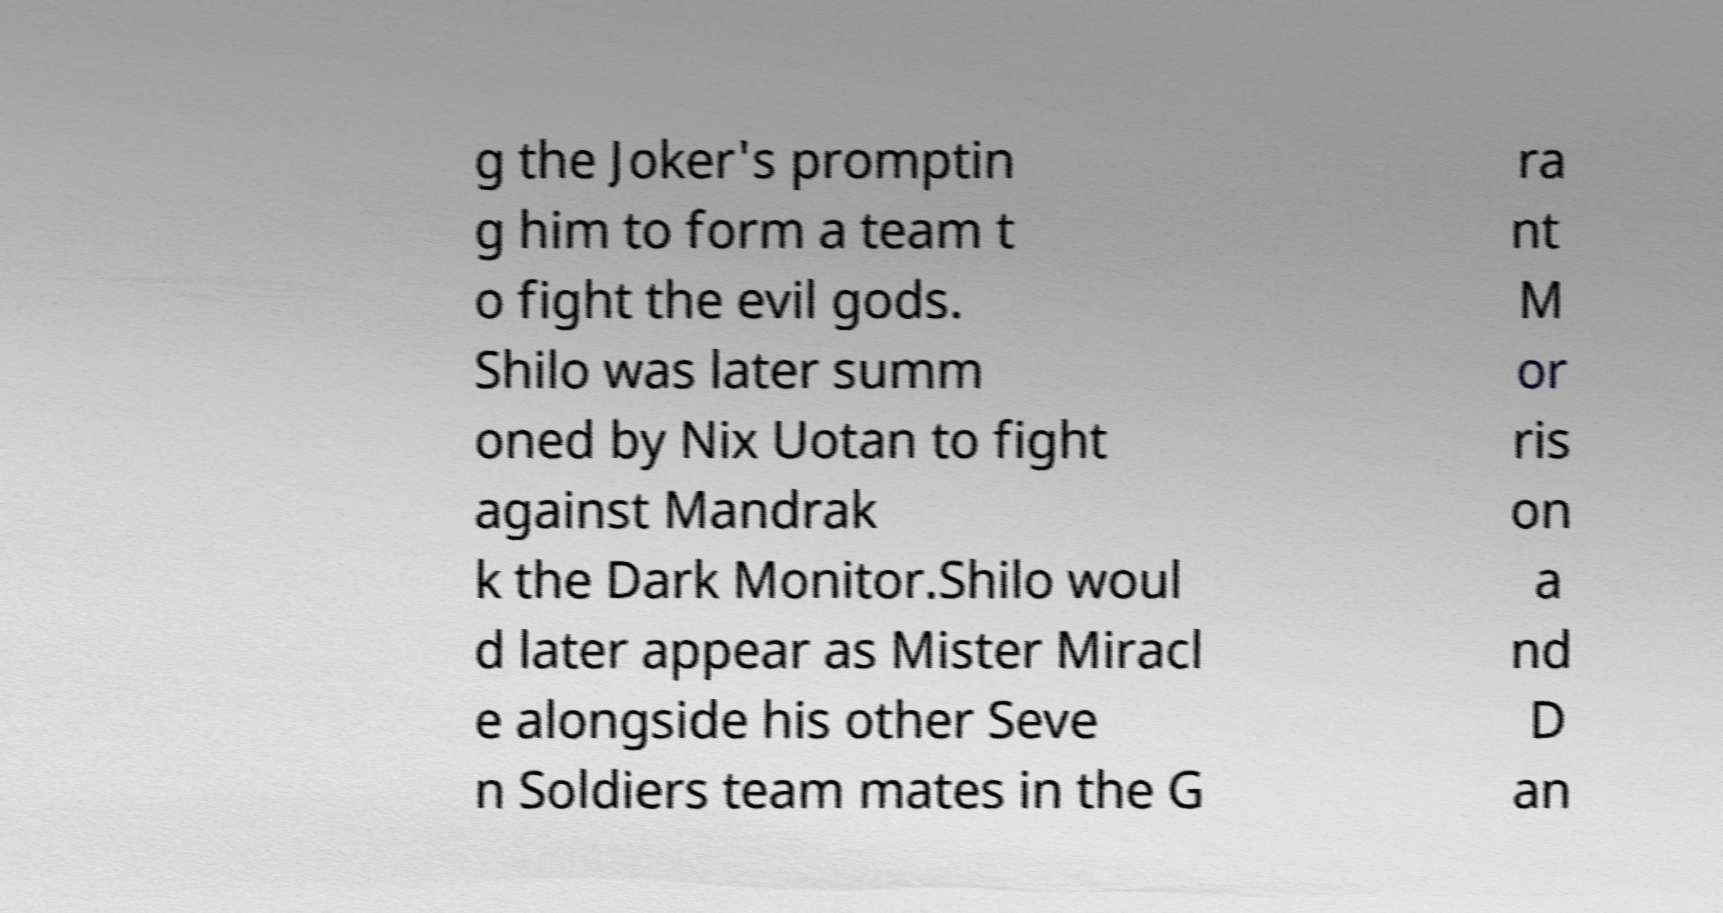Can you accurately transcribe the text from the provided image for me? g the Joker's promptin g him to form a team t o fight the evil gods. Shilo was later summ oned by Nix Uotan to fight against Mandrak k the Dark Monitor.Shilo woul d later appear as Mister Miracl e alongside his other Seve n Soldiers team mates in the G ra nt M or ris on a nd D an 